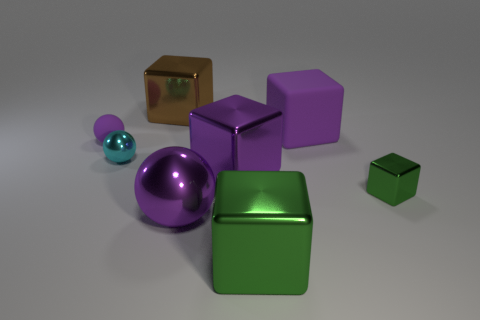Add 1 tiny gray metallic spheres. How many objects exist? 9 Subtract all rubber cubes. How many cubes are left? 4 Subtract all gray cylinders. How many purple spheres are left? 2 Subtract all green cubes. How many cubes are left? 3 Subtract all cubes. How many objects are left? 3 Subtract all gray blocks. Subtract all gray balls. How many blocks are left? 5 Subtract all rubber objects. Subtract all big purple blocks. How many objects are left? 4 Add 4 brown cubes. How many brown cubes are left? 5 Add 3 brown rubber things. How many brown rubber things exist? 3 Subtract 0 gray blocks. How many objects are left? 8 